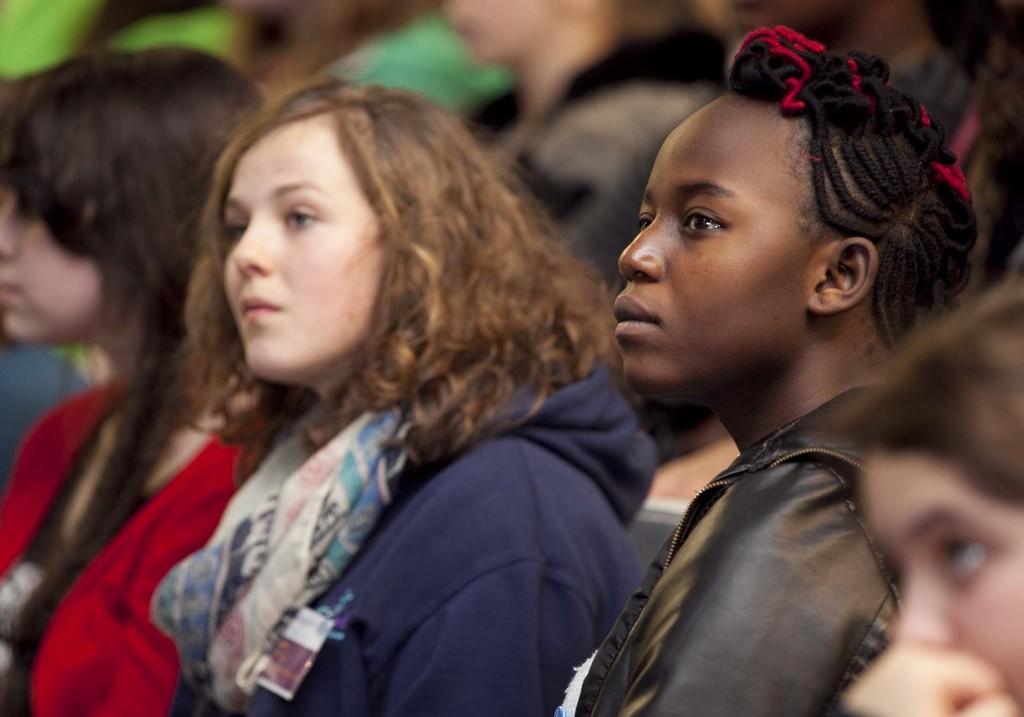How would you summarize this image in a sentence or two? There are persons in different color dresses, watching something. And the background is blurred. 